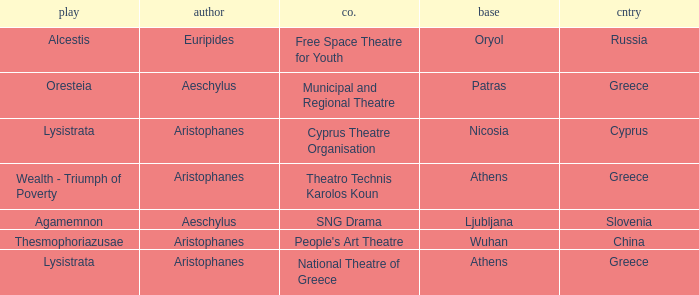What is the country when the base is ljubljana? Slovenia. 